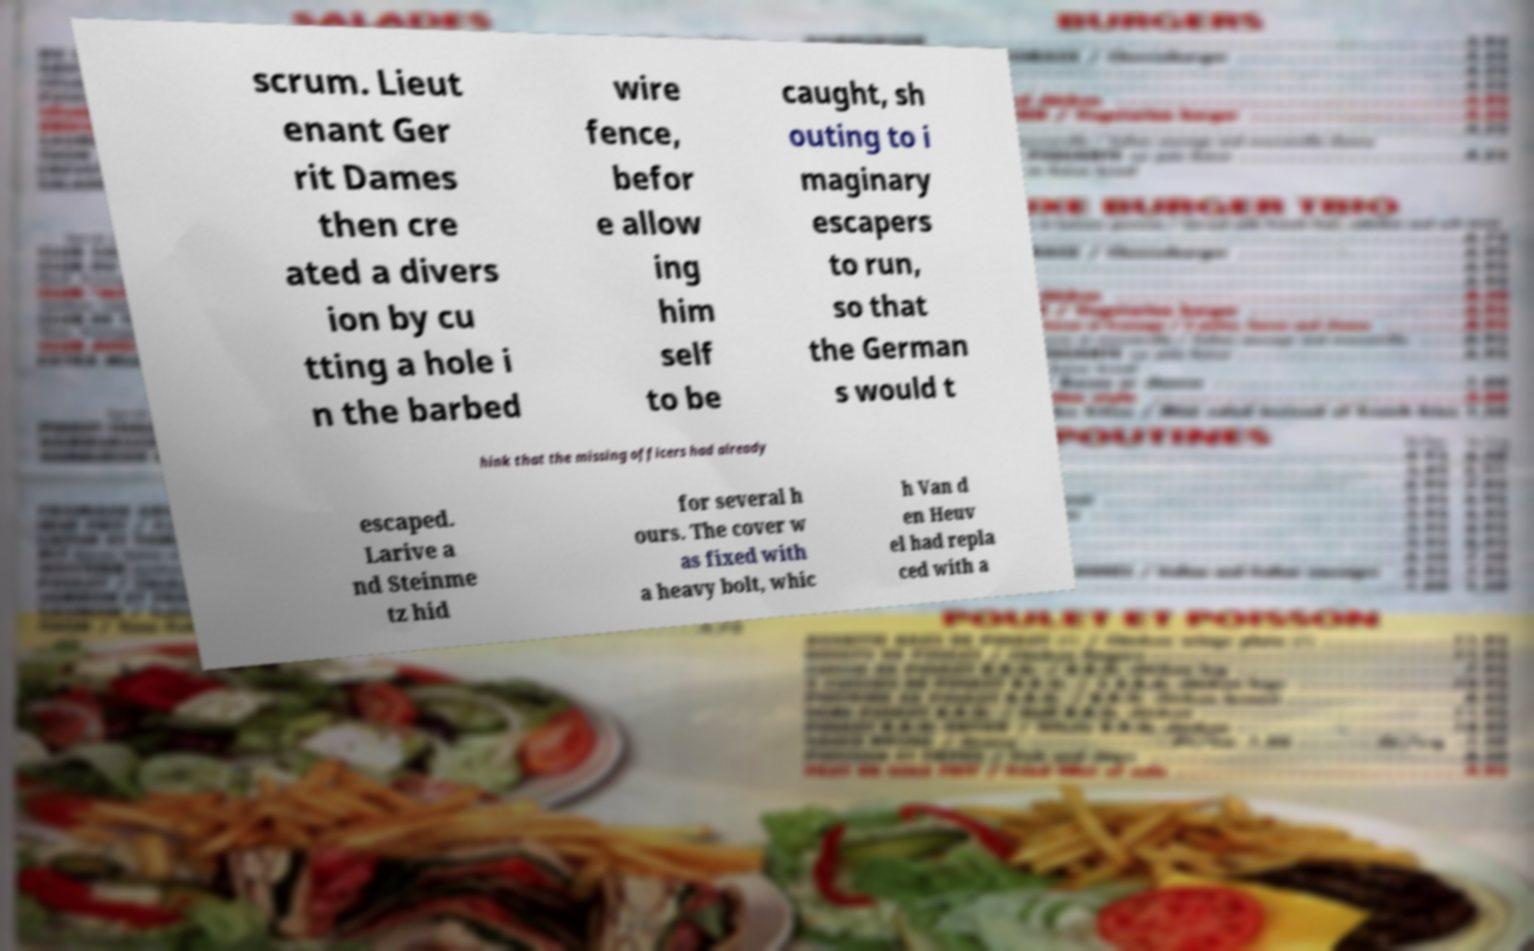There's text embedded in this image that I need extracted. Can you transcribe it verbatim? scrum. Lieut enant Ger rit Dames then cre ated a divers ion by cu tting a hole i n the barbed wire fence, befor e allow ing him self to be caught, sh outing to i maginary escapers to run, so that the German s would t hink that the missing officers had already escaped. Larive a nd Steinme tz hid for several h ours. The cover w as fixed with a heavy bolt, whic h Van d en Heuv el had repla ced with a 